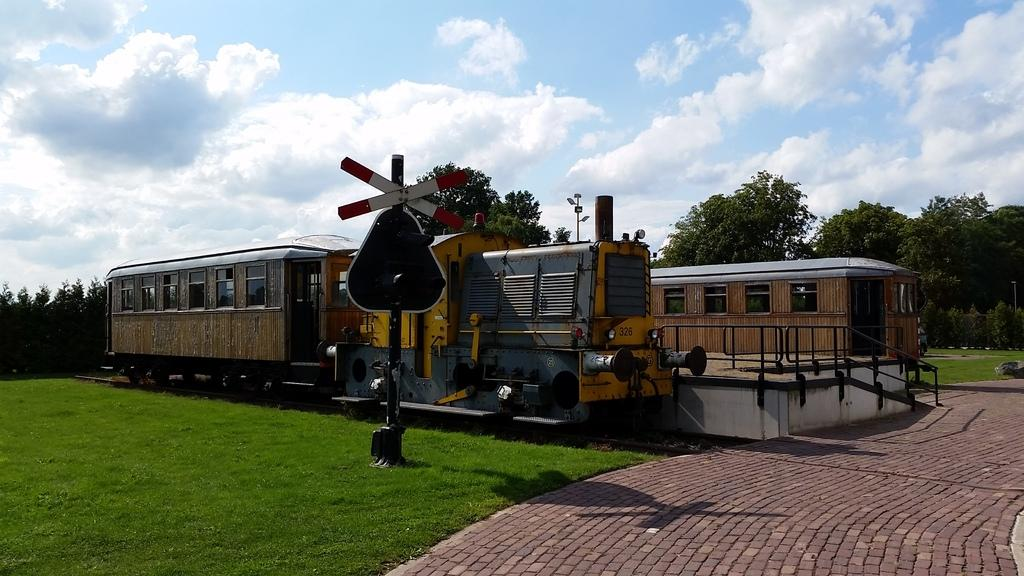What type of natural elements can be seen in the image? There are trees in the image. What man-made objects are present in the image? There are trains and a sign board in the image. What is visible in the sky in the image? There are clouds in the sky. Can you see a plastic crowd in the image? There is no plastic crowd present in the image. What type of fog can be seen in the image? There is no fog visible in the image; only clouds are present in the sky. 